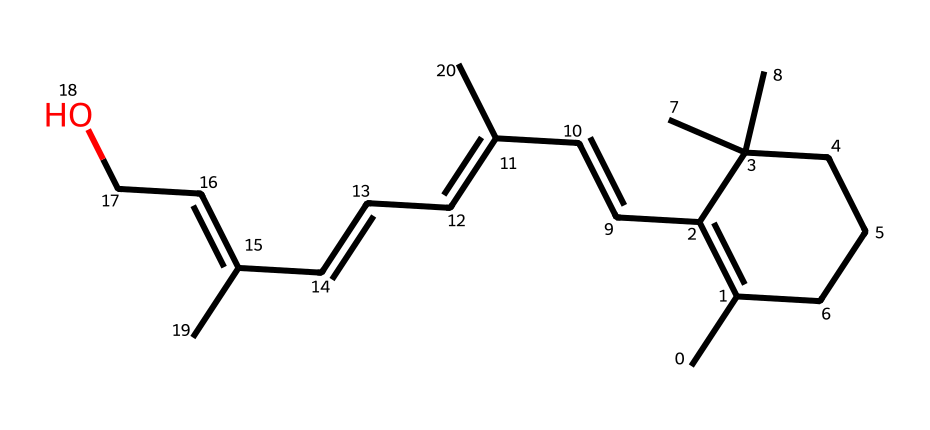What is the primary functional group present in retinol? The chemical structure of retinol is characterized by a hydroxyl (-OH) group, indicating it belongs to the alcohol functional group family. This is seen at the end of the molecule attached to a carbon atom.
Answer: hydroxyl How many carbon atoms are present in retinol? By examining the SMILES representation, we can count the number of carbon atoms in the structure. Each "C" represents a carbon atom, and in this case, there are 20 carbon atoms linked in various configurations.
Answer: 20 Is retinol more likely to be found as a saturated or unsaturated compound? The chemical structure includes multiple double bonds, as observed in the chain where C=C bonds are present, indicating that retinol is classified as an unsaturated compound.
Answer: unsaturated What is the significance of retinol in skincare? Retinol is known for its role in promoting cell turnover and reducing signs of aging, which is reflected in its popularity among anti-aging skincare products.
Answer: anti-aging How many double bonds does retinol contain? By analyzing the structure, it is clear there are at least four double bonds based on the presence of C=C notations in the molecule, which is typical for retinol.
Answer: 4 Does retinol contain any aromatic rings? Observing the structure, there is no indication of cyclic carbon arrangements with alternating double bonds, which characterizes aromatic compounds; thus, it lacks aromatic rings.
Answer: no 